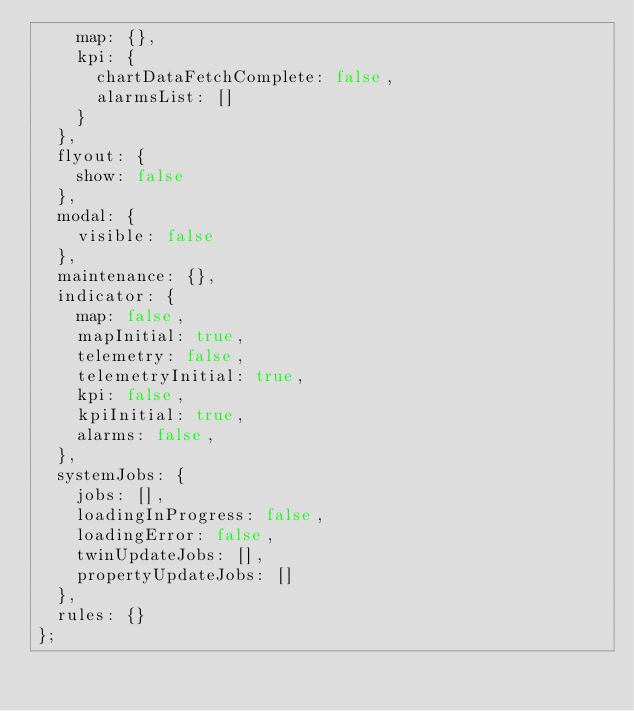<code> <loc_0><loc_0><loc_500><loc_500><_JavaScript_>    map: {},
    kpi: {
      chartDataFetchComplete: false,
      alarmsList: []
    }
  },
  flyout: {
    show: false
  },
  modal: {
    visible: false
  },
  maintenance: {},
  indicator: {
    map: false,
    mapInitial: true,
    telemetry: false,
    telemetryInitial: true,
    kpi: false,
    kpiInitial: true,
    alarms: false,
  },
  systemJobs: {
    jobs: [],
    loadingInProgress: false,
    loadingError: false,
    twinUpdateJobs: [],
    propertyUpdateJobs: []
  },
  rules: {}
};
</code> 